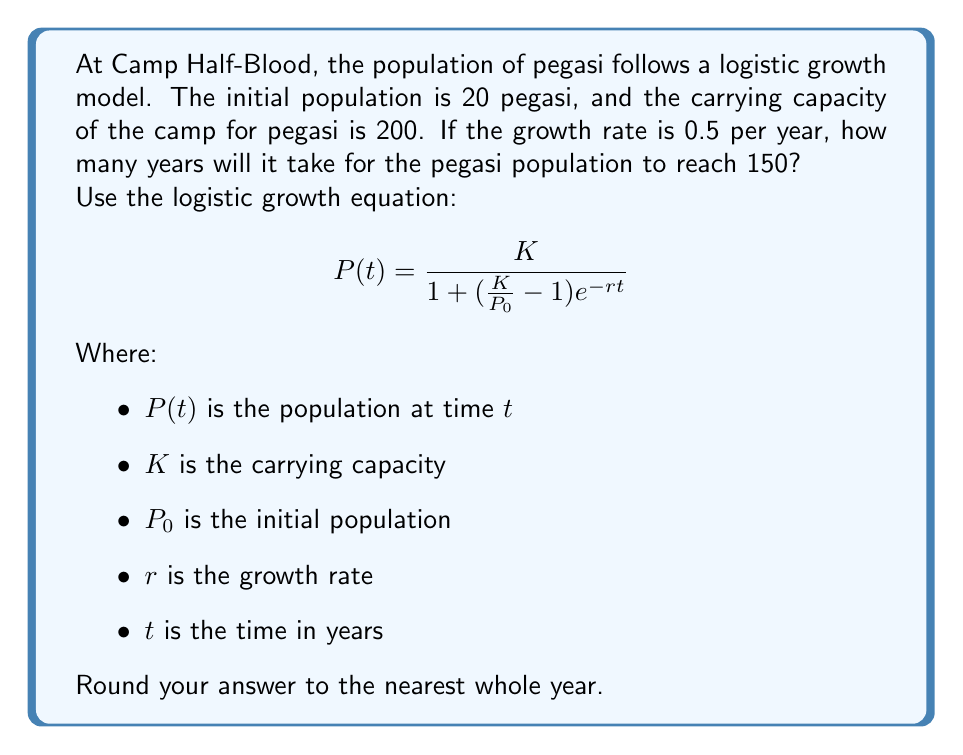What is the answer to this math problem? Let's approach this step-by-step:

1) We're given:
   $K = 200$ (carrying capacity)
   $P_0 = 20$ (initial population)
   $r = 0.5$ (growth rate)
   $P(t) = 150$ (target population)

2) We need to solve for $t$ in the logistic growth equation:

   $$150 = \frac{200}{1 + (\frac{200}{20} - 1)e^{-0.5t}}$$

3) Let's simplify the right side:

   $$150 = \frac{200}{1 + (10 - 1)e^{-0.5t}} = \frac{200}{1 + 9e^{-0.5t}}$$

4) Now, let's solve for $t$:

   $$150(1 + 9e^{-0.5t}) = 200$$
   $$150 + 1350e^{-0.5t} = 200$$
   $$1350e^{-0.5t} = 50$$
   $$e^{-0.5t} = \frac{1}{27}$$

5) Taking the natural log of both sides:

   $$-0.5t = \ln(\frac{1}{27})$$
   $$t = -2\ln(\frac{1}{27})$$

6) Simplify:

   $$t = -2(-3.2958) = 6.5916$$

7) Rounding to the nearest whole year:

   $$t \approx 7$$

Therefore, it will take approximately 7 years for the pegasi population to reach 150.
Answer: 7 years 